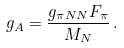Convert formula to latex. <formula><loc_0><loc_0><loc_500><loc_500>g _ { A } = \frac { g _ { \pi N N } F _ { \pi } } { M _ { N } } \, .</formula> 